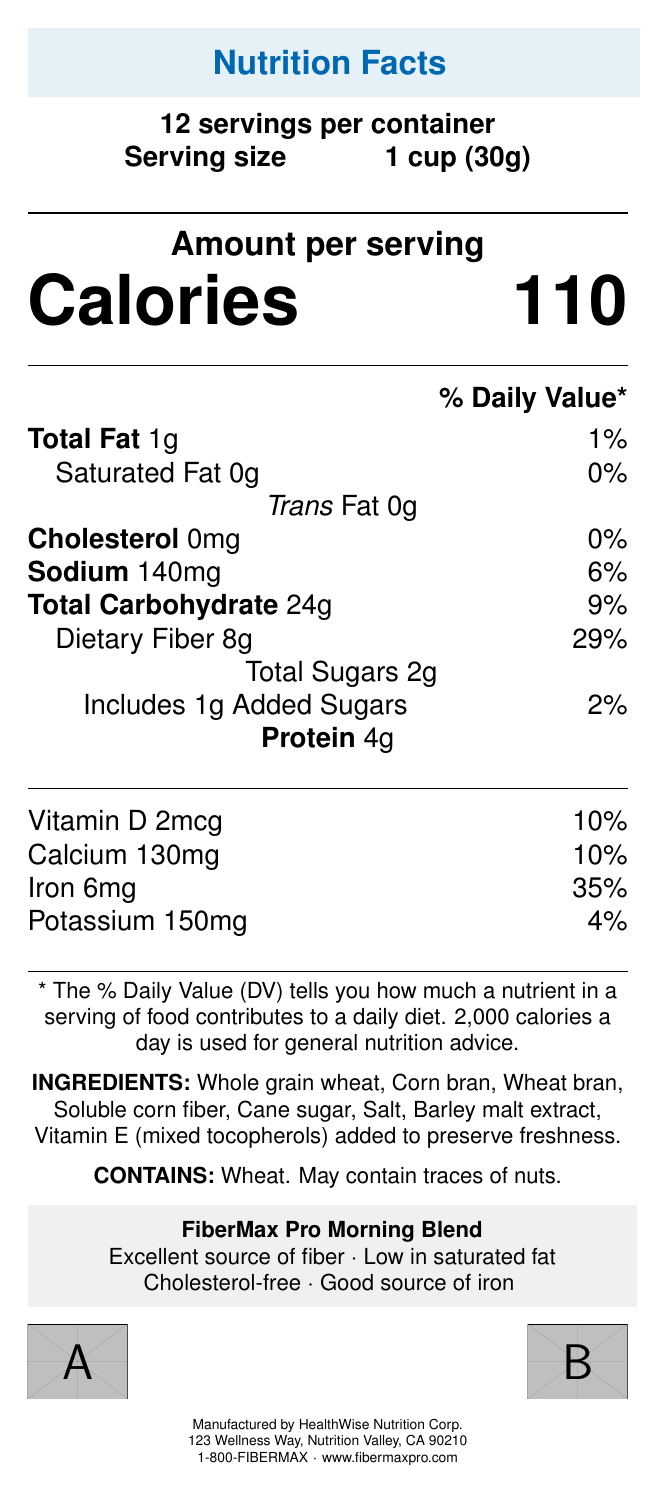what is the serving size? The document specifies that the serving size is 1 cup (30g).
Answer: 1 cup (30g) how many calories are there per serving? The document states that each serving contains 110 calories.
Answer: 110 how much dietary fiber is in each serving? The Nutrition Facts label shows that there are 8g of dietary fiber per serving.
Answer: 8g how much protein does each serving of FiberMax Pro Morning Blend contain? The document indicates that each serving contains 4g of protein.
Answer: 4g what are the first three ingredients listed? The ingredients listed in order are Whole grain wheat, Corn bran, and Wheat bran.
Answer: Whole grain wheat, Corn bran, Wheat bran which of the following statements is a claim made by the product? A. High in saturated fat B. Low in fiber C. Cholesterol-free D. Poor source of iron The claim statements in the document include "Cholesterol-free".
Answer: C how much sodium is in each serving? A. 0mg B. 140mg C. 200mg D. 300mg The document states that there are 140mg of sodium per serving.
Answer: B is the product a good source of iron? The document mentions that the product is a good source of iron.
Answer: Yes does the cereal contain any allergens? The document specifies that the cereal contains wheat and may contain traces of nuts.
Answer: Yes describe the main features and marketing points of FiberMax Pro Morning Blend. The document highlights several attributes and benefits of FiberMax Pro Morning Blend, targeting health-conscious professionals by emphasizing its nutritional benefits (fiber content, low fat, etc.), convenience, and certifications.
Answer: The main features of FiberMax Pro Morning Blend include it being an excellent source of fiber, low in saturated fat, cholesterol-free, and a good source of iron. The marketing points emphasize that the cereal supports digestive health, helps maintain steady energy levels, promotes a feeling of fullness for busy professionals, and is a convenient and quick breakfast option for on-the-go executives. The product is also Non-GMO Project Verified and has the Whole Grain Council Stamp. what vitamin is included, and what percentage of the daily value does it provide? The document lists Vitamin D at 2mcg per serving, contributing to 10% of the daily value.
Answer: Vitamin D, 10% how much added sugar is in each serving? The document states there is 1g of added sugars per serving.
Answer: 1g what is the suggested retail price of each unit? The document does not visually provide the suggested retail price; this information cannot be determined from the label alone.
Answer: Not enough information 